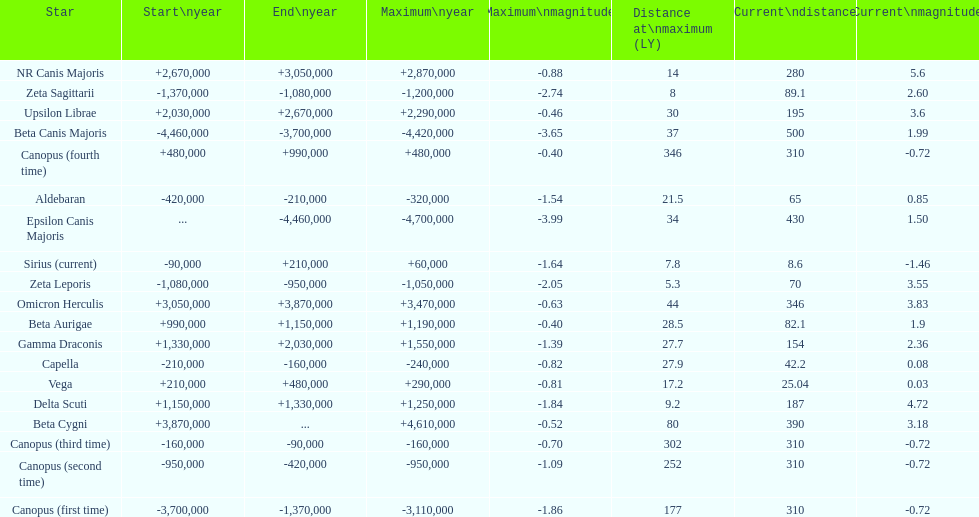What is the number of stars that have a maximum magnitude less than zero? 5. 